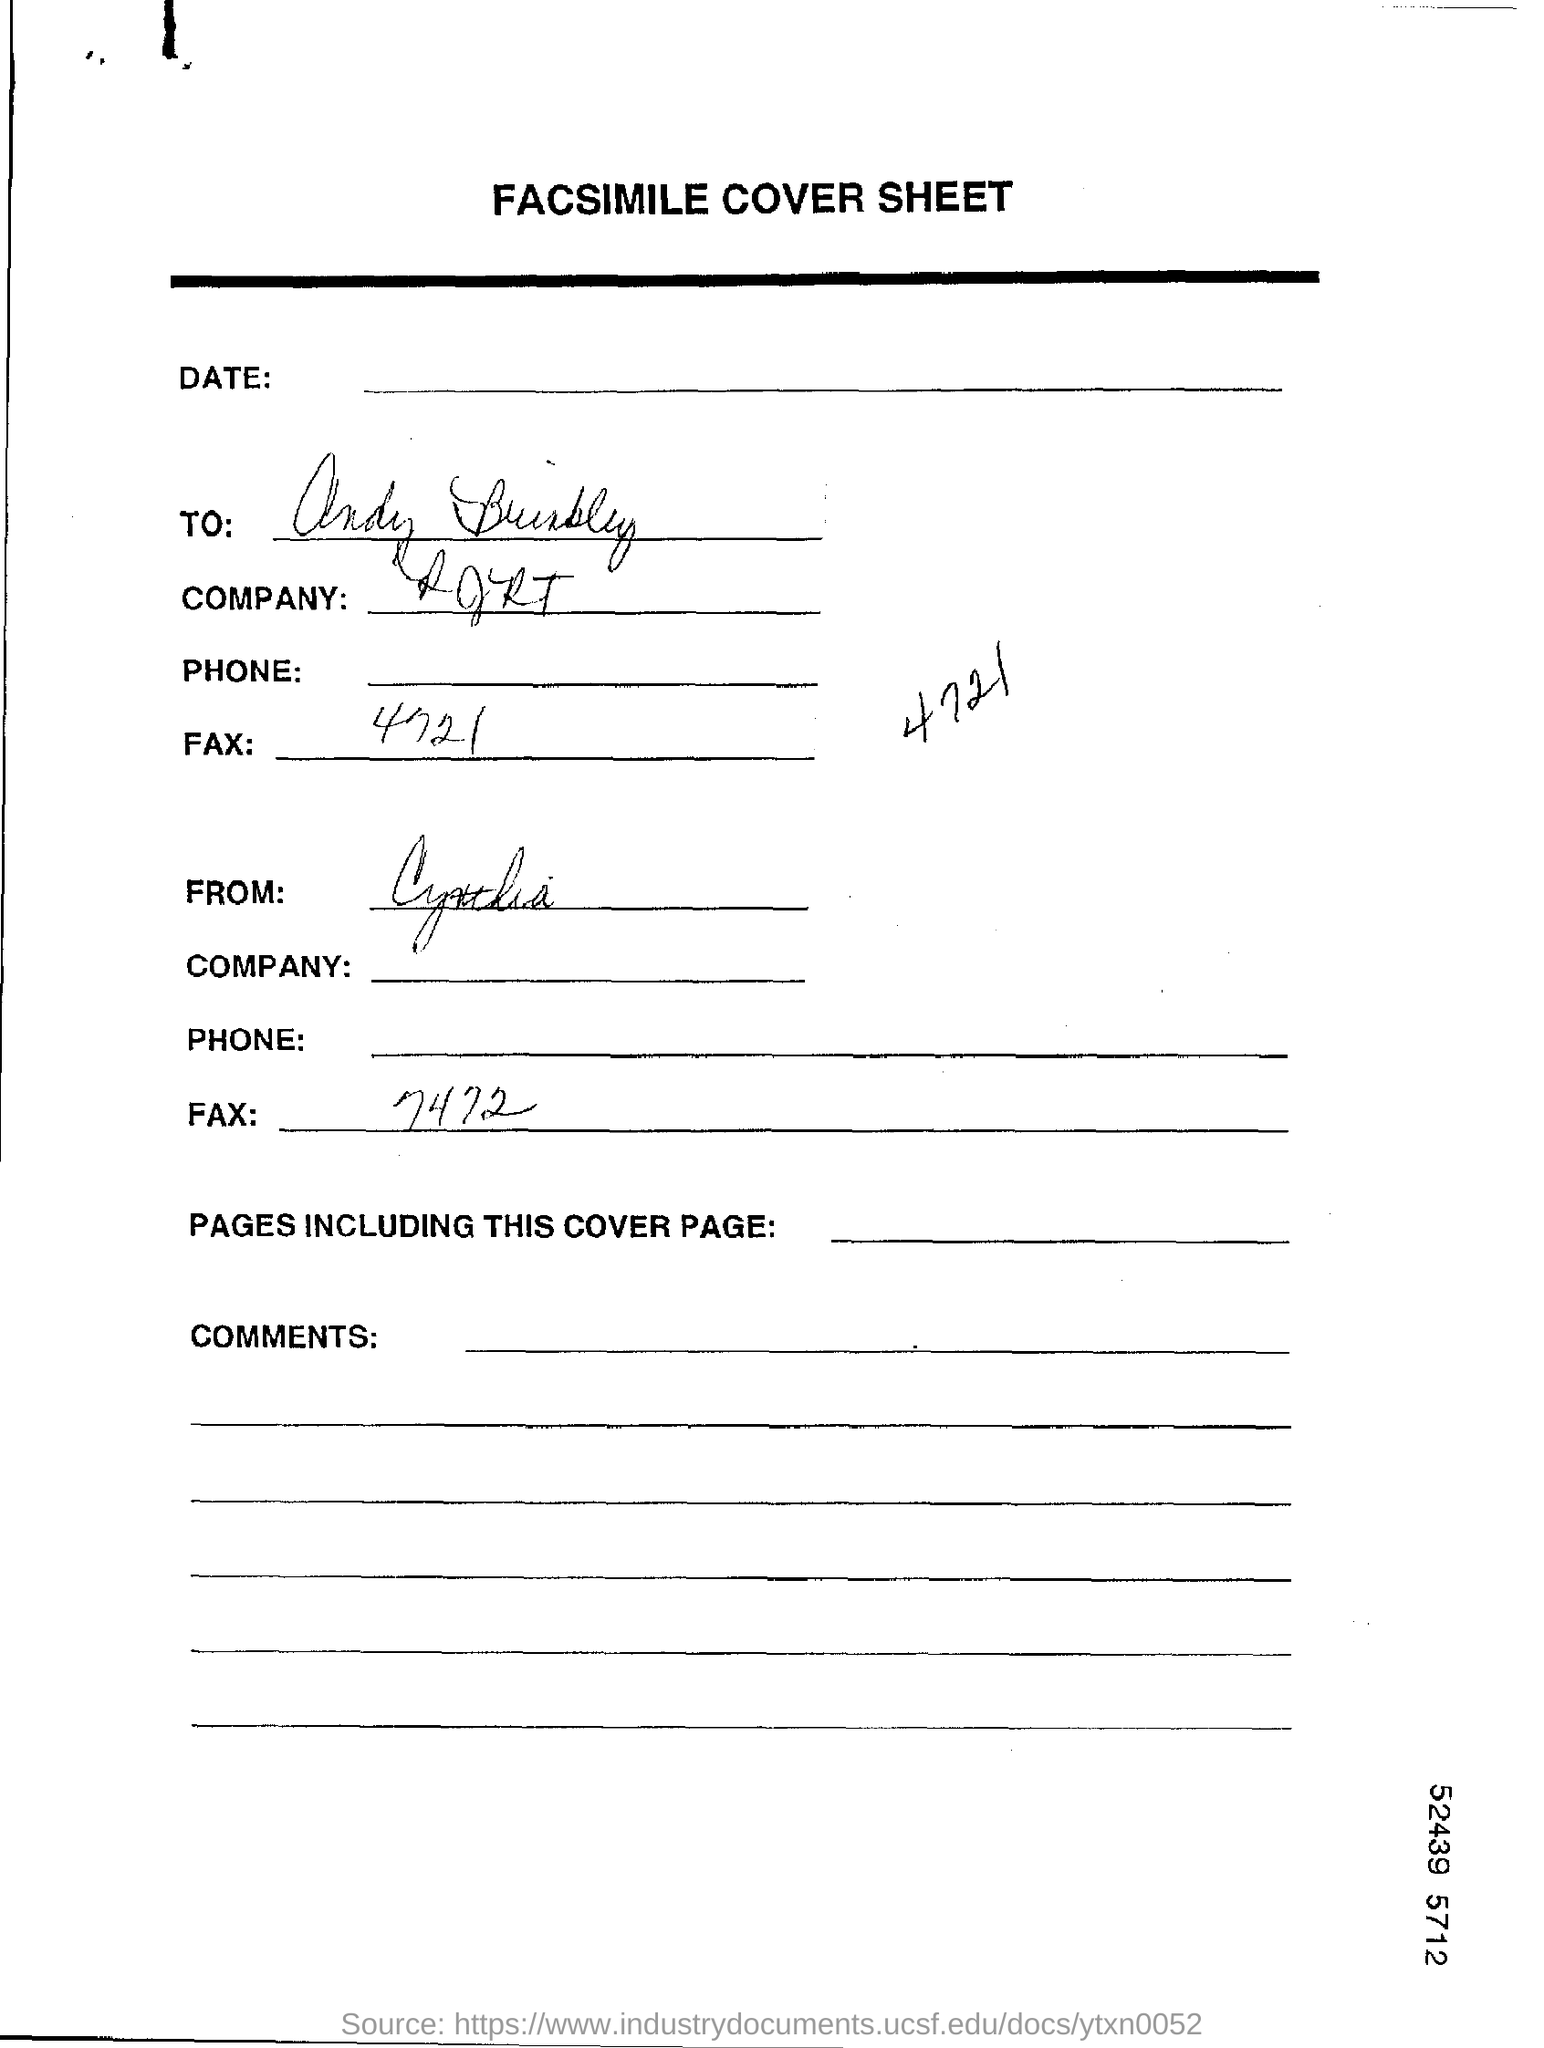List a handful of essential elements in this visual. The heading of the page is "Facsimile Cover Sheet. 